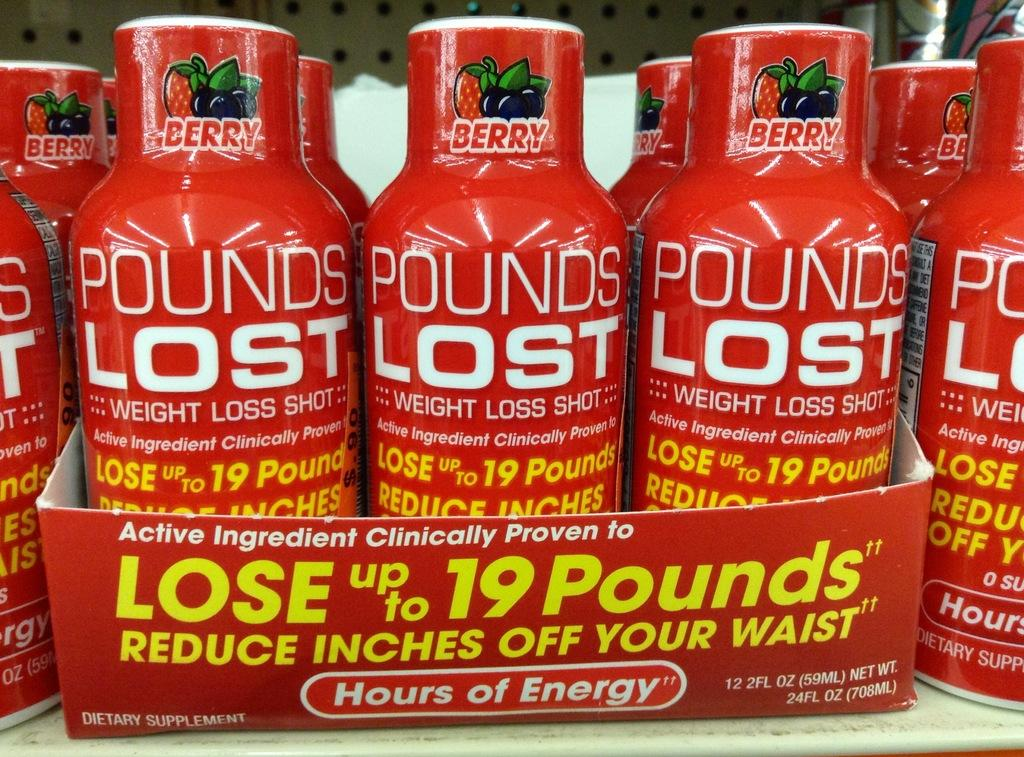<image>
Provide a brief description of the given image. Four bottles on display three of which are in a case and they are red with white letters that say Pounds Lost on the front. 